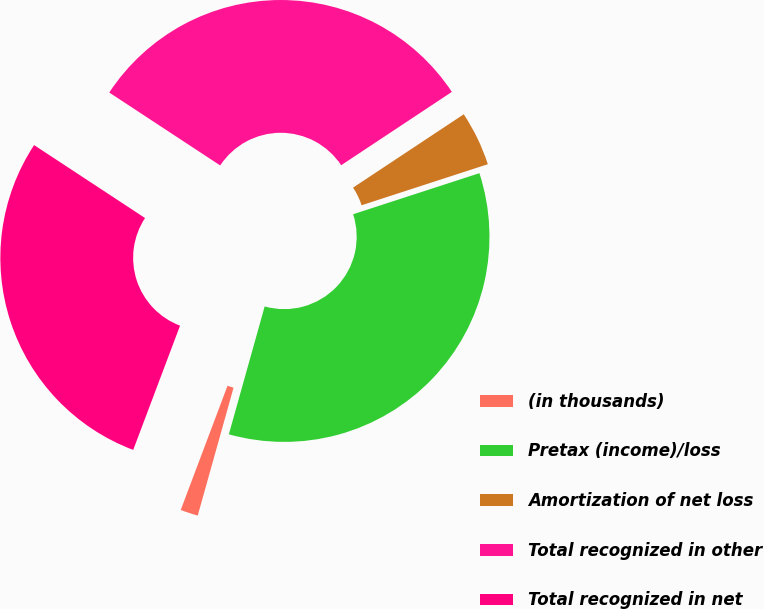<chart> <loc_0><loc_0><loc_500><loc_500><pie_chart><fcel>(in thousands)<fcel>Pretax (income)/loss<fcel>Amortization of net loss<fcel>Total recognized in other<fcel>Total recognized in net<nl><fcel>1.39%<fcel>34.35%<fcel>4.31%<fcel>31.43%<fcel>28.52%<nl></chart> 